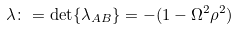<formula> <loc_0><loc_0><loc_500><loc_500>\lambda \colon = \det \{ \lambda _ { A B } \} = - ( 1 - \Omega ^ { 2 } \rho ^ { 2 } )</formula> 